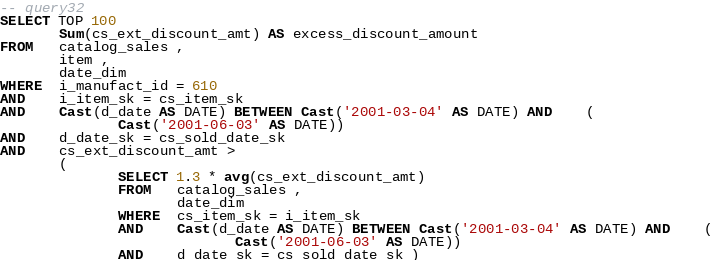Convert code to text. <code><loc_0><loc_0><loc_500><loc_500><_SQL_>-- query32
SELECT TOP 100
       Sum(cs_ext_discount_amt) AS excess_discount_amount
FROM   catalog_sales , 
       item , 
       date_dim 
WHERE  i_manufact_id = 610 
AND    i_item_sk = cs_item_sk 
AND    Cast(d_date AS DATE) BETWEEN Cast('2001-03-04' AS DATE) AND    ( 
              Cast('2001-06-03' AS DATE)) 
AND    d_date_sk = cs_sold_date_sk 
AND    cs_ext_discount_amt > 
       ( 
              SELECT 1.3 * avg(cs_ext_discount_amt) 
              FROM   catalog_sales , 
                     date_dim 
              WHERE  cs_item_sk = i_item_sk 
              AND    Cast(d_date AS DATE) BETWEEN Cast('2001-03-04' AS DATE) AND    ( 
                            Cast('2001-06-03' AS DATE)) 
              AND    d_date_sk = cs_sold_date_sk ) 
</code> 